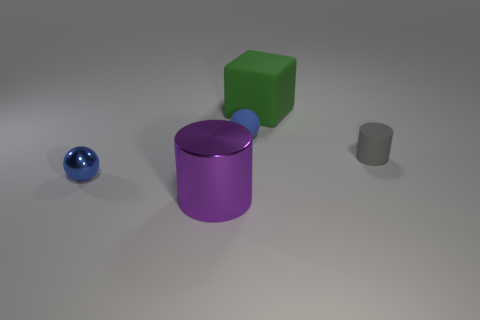Subtract all blue spheres. How many were subtracted if there are1blue spheres left? 1 Add 1 brown metallic cylinders. How many objects exist? 6 Subtract 1 cubes. How many cubes are left? 0 Subtract all cubes. How many objects are left? 4 Add 3 blue matte things. How many blue matte things are left? 4 Add 4 metallic cylinders. How many metallic cylinders exist? 5 Subtract 1 gray cylinders. How many objects are left? 4 Subtract all gray cylinders. Subtract all cyan cubes. How many cylinders are left? 1 Subtract all purple blocks. How many brown balls are left? 0 Subtract all matte spheres. Subtract all tiny blue matte cylinders. How many objects are left? 4 